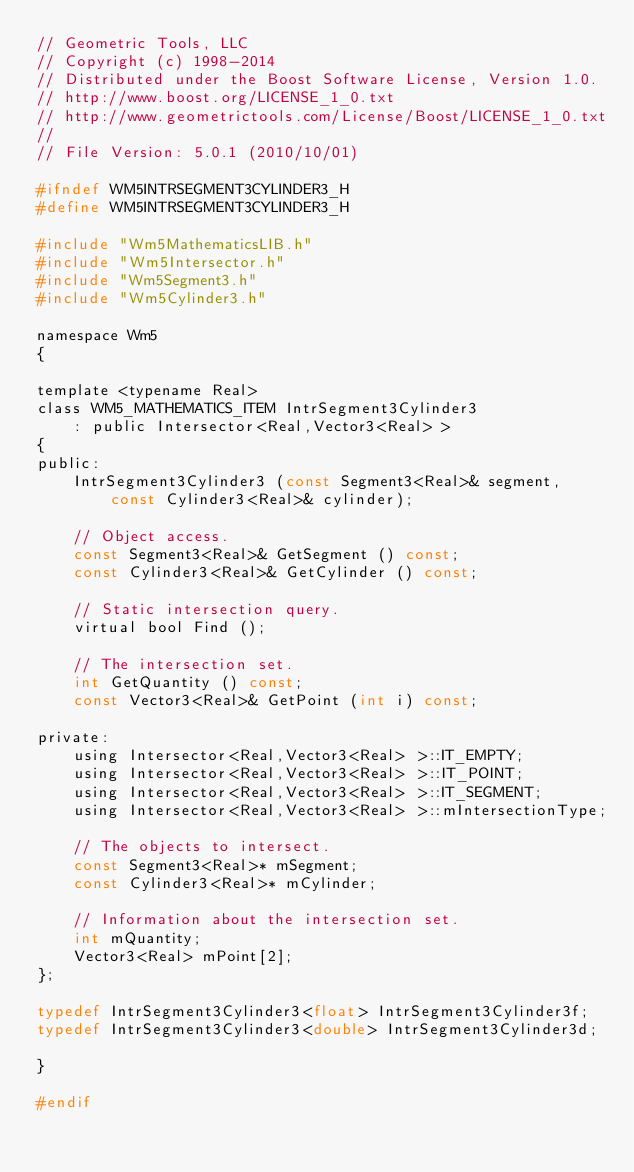<code> <loc_0><loc_0><loc_500><loc_500><_C_>// Geometric Tools, LLC
// Copyright (c) 1998-2014
// Distributed under the Boost Software License, Version 1.0.
// http://www.boost.org/LICENSE_1_0.txt
// http://www.geometrictools.com/License/Boost/LICENSE_1_0.txt
//
// File Version: 5.0.1 (2010/10/01)

#ifndef WM5INTRSEGMENT3CYLINDER3_H
#define WM5INTRSEGMENT3CYLINDER3_H

#include "Wm5MathematicsLIB.h"
#include "Wm5Intersector.h"
#include "Wm5Segment3.h"
#include "Wm5Cylinder3.h"

namespace Wm5
{

template <typename Real>
class WM5_MATHEMATICS_ITEM IntrSegment3Cylinder3
    : public Intersector<Real,Vector3<Real> >
{
public:
    IntrSegment3Cylinder3 (const Segment3<Real>& segment,
        const Cylinder3<Real>& cylinder);

    // Object access.
    const Segment3<Real>& GetSegment () const;
    const Cylinder3<Real>& GetCylinder () const;

    // Static intersection query.
    virtual bool Find ();

    // The intersection set.
    int GetQuantity () const;
    const Vector3<Real>& GetPoint (int i) const;

private:
    using Intersector<Real,Vector3<Real> >::IT_EMPTY;
    using Intersector<Real,Vector3<Real> >::IT_POINT;
    using Intersector<Real,Vector3<Real> >::IT_SEGMENT;
    using Intersector<Real,Vector3<Real> >::mIntersectionType;

    // The objects to intersect.
    const Segment3<Real>* mSegment;
    const Cylinder3<Real>* mCylinder;

    // Information about the intersection set.
    int mQuantity;
    Vector3<Real> mPoint[2];
};

typedef IntrSegment3Cylinder3<float> IntrSegment3Cylinder3f;
typedef IntrSegment3Cylinder3<double> IntrSegment3Cylinder3d;

}

#endif
</code> 